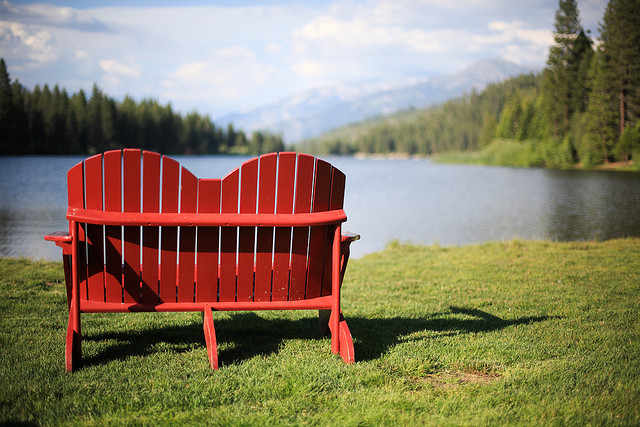Is this the ocean? No, this is not the ocean. It appears to be a serene lake situated in a beautiful, forested area surrounded by mountains. 